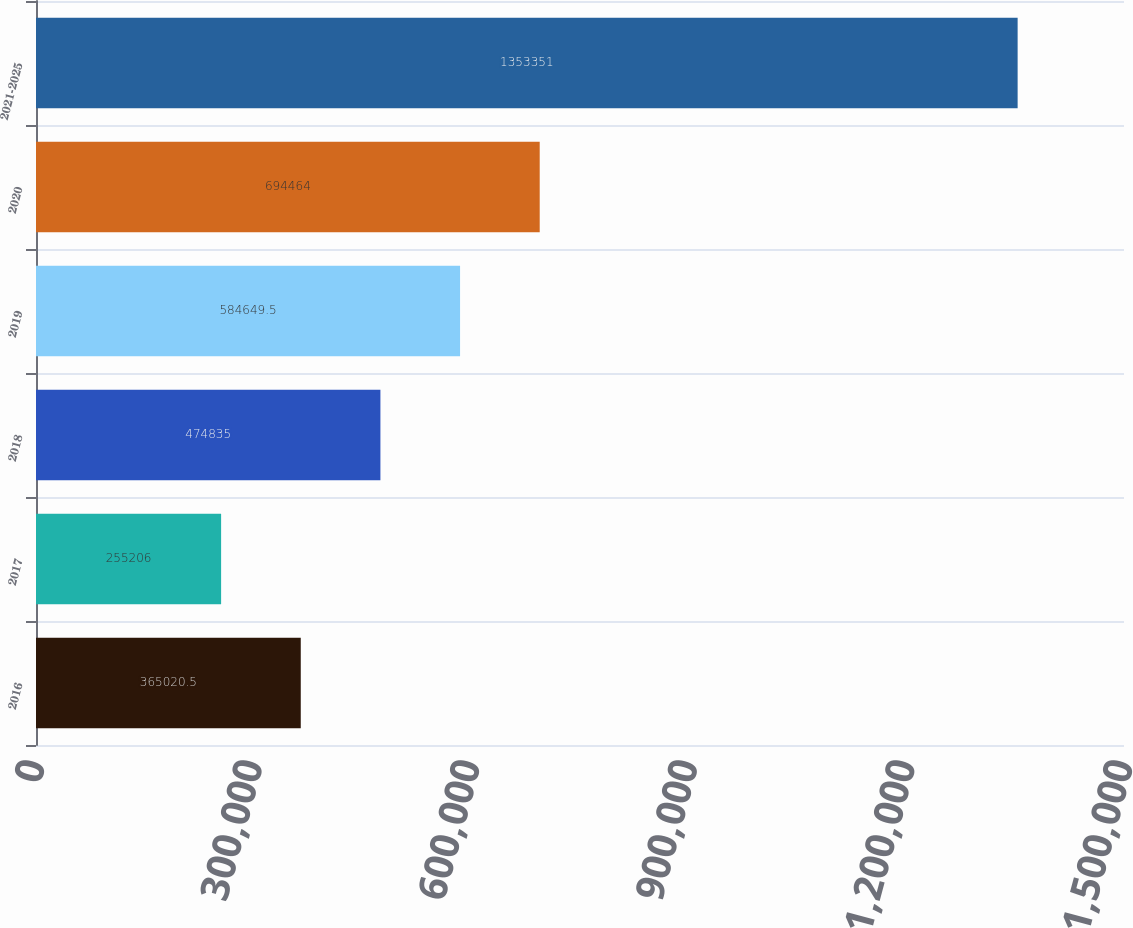Convert chart to OTSL. <chart><loc_0><loc_0><loc_500><loc_500><bar_chart><fcel>2016<fcel>2017<fcel>2018<fcel>2019<fcel>2020<fcel>2021-2025<nl><fcel>365020<fcel>255206<fcel>474835<fcel>584650<fcel>694464<fcel>1.35335e+06<nl></chart> 